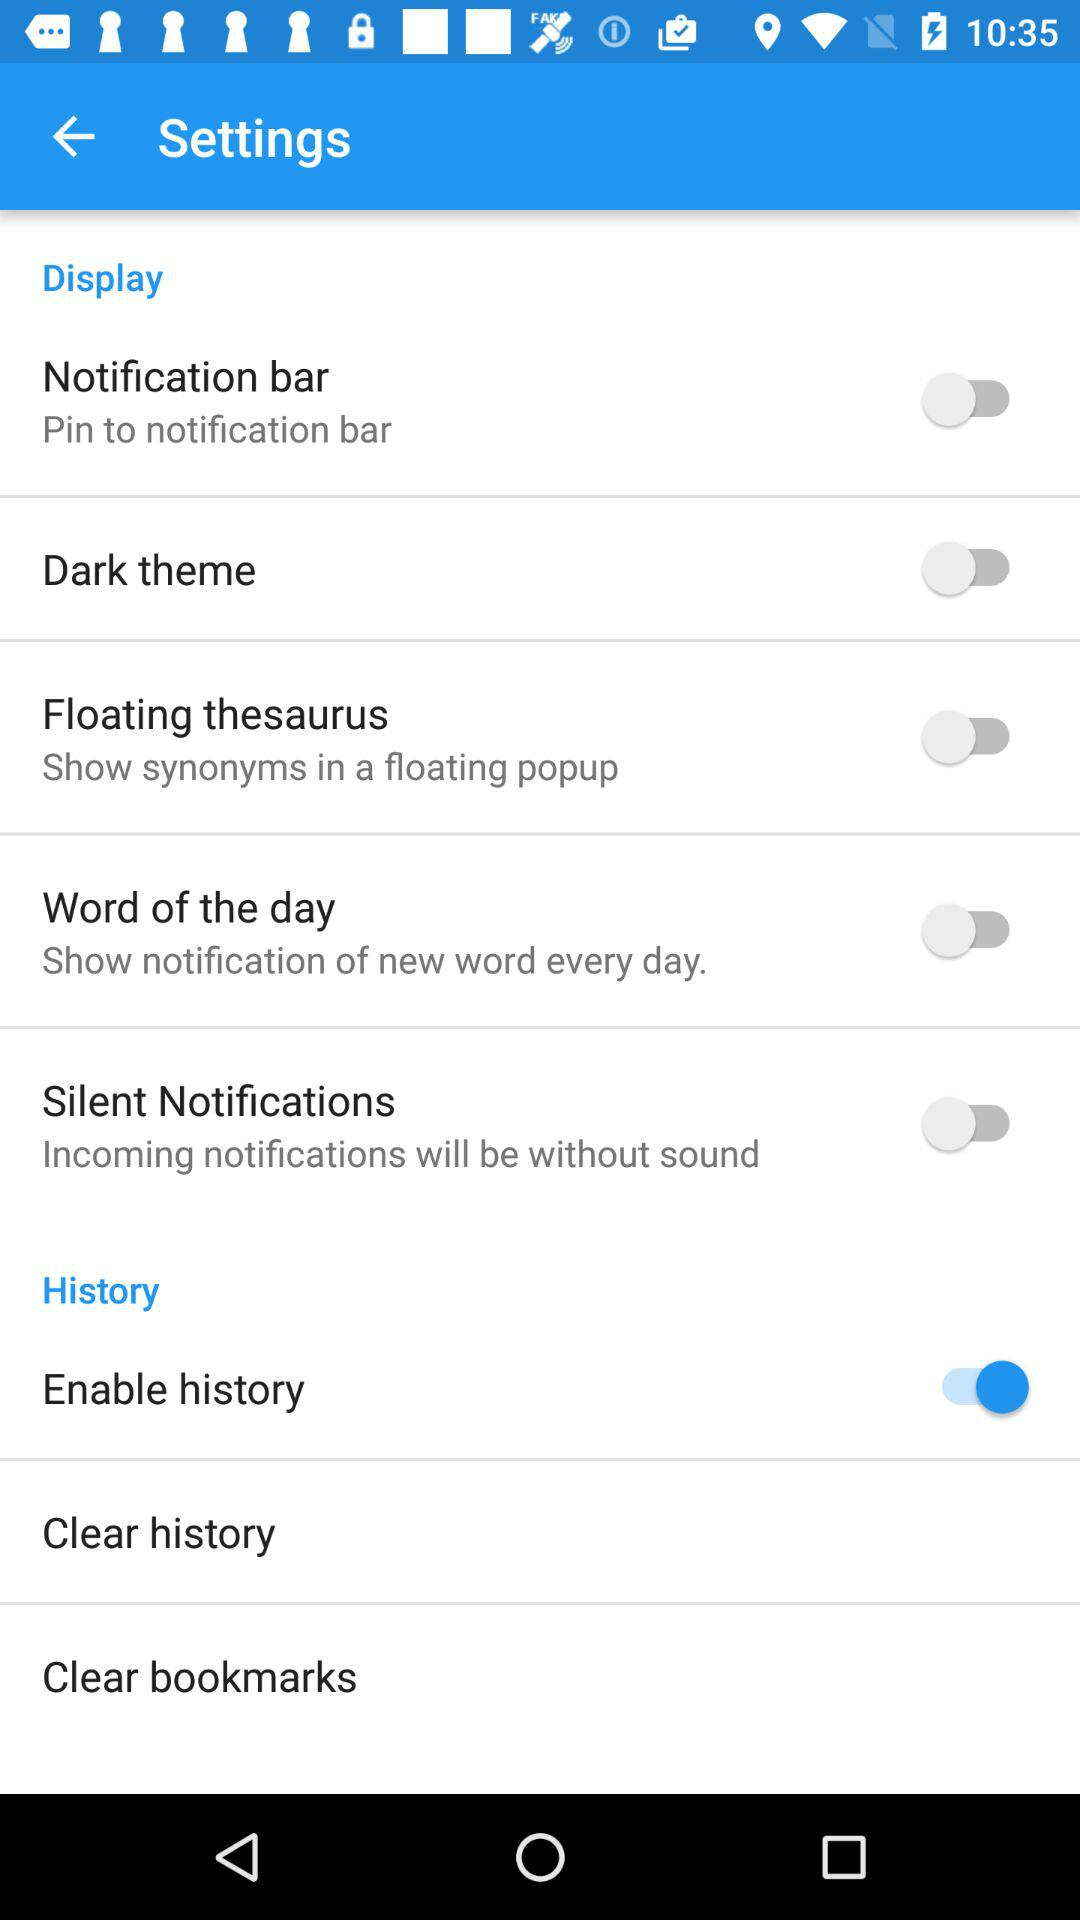What is the status of history? The status is "on". 